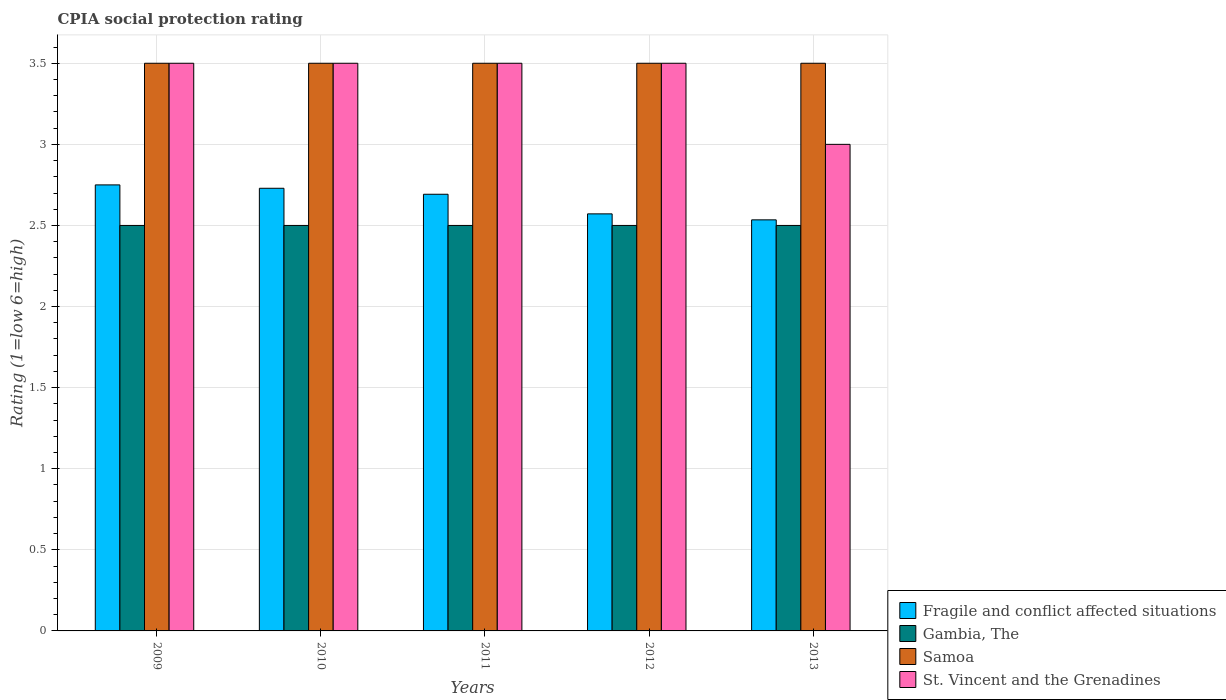How many groups of bars are there?
Your response must be concise. 5. Are the number of bars on each tick of the X-axis equal?
Offer a very short reply. Yes. In how many cases, is the number of bars for a given year not equal to the number of legend labels?
Give a very brief answer. 0. Across all years, what is the minimum CPIA rating in Fragile and conflict affected situations?
Offer a terse response. 2.53. What is the total CPIA rating in Gambia, The in the graph?
Provide a short and direct response. 12.5. What is the difference between the CPIA rating in St. Vincent and the Grenadines in 2010 and that in 2013?
Your answer should be very brief. 0.5. What is the difference between the CPIA rating in St. Vincent and the Grenadines in 2010 and the CPIA rating in Fragile and conflict affected situations in 2012?
Ensure brevity in your answer.  0.93. What is the average CPIA rating in Fragile and conflict affected situations per year?
Your answer should be very brief. 2.66. Is the difference between the CPIA rating in Gambia, The in 2011 and 2012 greater than the difference between the CPIA rating in Samoa in 2011 and 2012?
Provide a succinct answer. No. What is the difference between the highest and the second highest CPIA rating in St. Vincent and the Grenadines?
Your response must be concise. 0. Is it the case that in every year, the sum of the CPIA rating in Gambia, The and CPIA rating in Samoa is greater than the sum of CPIA rating in Fragile and conflict affected situations and CPIA rating in St. Vincent and the Grenadines?
Provide a short and direct response. No. What does the 2nd bar from the left in 2010 represents?
Give a very brief answer. Gambia, The. What does the 3rd bar from the right in 2009 represents?
Offer a very short reply. Gambia, The. Is it the case that in every year, the sum of the CPIA rating in Samoa and CPIA rating in Fragile and conflict affected situations is greater than the CPIA rating in Gambia, The?
Make the answer very short. Yes. How many years are there in the graph?
Your response must be concise. 5. What is the difference between two consecutive major ticks on the Y-axis?
Give a very brief answer. 0.5. Does the graph contain grids?
Your answer should be compact. Yes. What is the title of the graph?
Ensure brevity in your answer.  CPIA social protection rating. Does "Virgin Islands" appear as one of the legend labels in the graph?
Your response must be concise. No. What is the label or title of the X-axis?
Keep it short and to the point. Years. What is the label or title of the Y-axis?
Keep it short and to the point. Rating (1=low 6=high). What is the Rating (1=low 6=high) of Fragile and conflict affected situations in 2009?
Ensure brevity in your answer.  2.75. What is the Rating (1=low 6=high) in Fragile and conflict affected situations in 2010?
Ensure brevity in your answer.  2.73. What is the Rating (1=low 6=high) of Fragile and conflict affected situations in 2011?
Your answer should be compact. 2.69. What is the Rating (1=low 6=high) of Samoa in 2011?
Keep it short and to the point. 3.5. What is the Rating (1=low 6=high) in Fragile and conflict affected situations in 2012?
Provide a short and direct response. 2.57. What is the Rating (1=low 6=high) in Gambia, The in 2012?
Keep it short and to the point. 2.5. What is the Rating (1=low 6=high) of Samoa in 2012?
Provide a succinct answer. 3.5. What is the Rating (1=low 6=high) in Fragile and conflict affected situations in 2013?
Provide a succinct answer. 2.53. What is the Rating (1=low 6=high) in Samoa in 2013?
Your answer should be compact. 3.5. Across all years, what is the maximum Rating (1=low 6=high) in Fragile and conflict affected situations?
Offer a very short reply. 2.75. Across all years, what is the maximum Rating (1=low 6=high) in Gambia, The?
Make the answer very short. 2.5. Across all years, what is the minimum Rating (1=low 6=high) of Fragile and conflict affected situations?
Give a very brief answer. 2.53. Across all years, what is the minimum Rating (1=low 6=high) of Samoa?
Offer a terse response. 3.5. Across all years, what is the minimum Rating (1=low 6=high) in St. Vincent and the Grenadines?
Provide a short and direct response. 3. What is the total Rating (1=low 6=high) in Fragile and conflict affected situations in the graph?
Ensure brevity in your answer.  13.28. What is the total Rating (1=low 6=high) of St. Vincent and the Grenadines in the graph?
Provide a succinct answer. 17. What is the difference between the Rating (1=low 6=high) of Fragile and conflict affected situations in 2009 and that in 2010?
Provide a succinct answer. 0.02. What is the difference between the Rating (1=low 6=high) in Gambia, The in 2009 and that in 2010?
Your answer should be compact. 0. What is the difference between the Rating (1=low 6=high) of Samoa in 2009 and that in 2010?
Your response must be concise. 0. What is the difference between the Rating (1=low 6=high) of St. Vincent and the Grenadines in 2009 and that in 2010?
Offer a terse response. 0. What is the difference between the Rating (1=low 6=high) of Fragile and conflict affected situations in 2009 and that in 2011?
Offer a terse response. 0.06. What is the difference between the Rating (1=low 6=high) in Samoa in 2009 and that in 2011?
Ensure brevity in your answer.  0. What is the difference between the Rating (1=low 6=high) in St. Vincent and the Grenadines in 2009 and that in 2011?
Provide a short and direct response. 0. What is the difference between the Rating (1=low 6=high) of Fragile and conflict affected situations in 2009 and that in 2012?
Your answer should be compact. 0.18. What is the difference between the Rating (1=low 6=high) in Gambia, The in 2009 and that in 2012?
Provide a short and direct response. 0. What is the difference between the Rating (1=low 6=high) of Samoa in 2009 and that in 2012?
Your answer should be compact. 0. What is the difference between the Rating (1=low 6=high) in Fragile and conflict affected situations in 2009 and that in 2013?
Make the answer very short. 0.22. What is the difference between the Rating (1=low 6=high) of Gambia, The in 2009 and that in 2013?
Make the answer very short. 0. What is the difference between the Rating (1=low 6=high) of Samoa in 2009 and that in 2013?
Your response must be concise. 0. What is the difference between the Rating (1=low 6=high) of St. Vincent and the Grenadines in 2009 and that in 2013?
Offer a very short reply. 0.5. What is the difference between the Rating (1=low 6=high) in Fragile and conflict affected situations in 2010 and that in 2011?
Your answer should be very brief. 0.04. What is the difference between the Rating (1=low 6=high) in Gambia, The in 2010 and that in 2011?
Provide a succinct answer. 0. What is the difference between the Rating (1=low 6=high) in Samoa in 2010 and that in 2011?
Offer a very short reply. 0. What is the difference between the Rating (1=low 6=high) of Fragile and conflict affected situations in 2010 and that in 2012?
Your answer should be compact. 0.16. What is the difference between the Rating (1=low 6=high) in Gambia, The in 2010 and that in 2012?
Make the answer very short. 0. What is the difference between the Rating (1=low 6=high) of Samoa in 2010 and that in 2012?
Your answer should be very brief. 0. What is the difference between the Rating (1=low 6=high) in Fragile and conflict affected situations in 2010 and that in 2013?
Offer a terse response. 0.19. What is the difference between the Rating (1=low 6=high) in Gambia, The in 2010 and that in 2013?
Provide a short and direct response. 0. What is the difference between the Rating (1=low 6=high) in Samoa in 2010 and that in 2013?
Your answer should be compact. 0. What is the difference between the Rating (1=low 6=high) in St. Vincent and the Grenadines in 2010 and that in 2013?
Provide a succinct answer. 0.5. What is the difference between the Rating (1=low 6=high) in Fragile and conflict affected situations in 2011 and that in 2012?
Provide a succinct answer. 0.12. What is the difference between the Rating (1=low 6=high) of Samoa in 2011 and that in 2012?
Provide a short and direct response. 0. What is the difference between the Rating (1=low 6=high) in St. Vincent and the Grenadines in 2011 and that in 2012?
Give a very brief answer. 0. What is the difference between the Rating (1=low 6=high) in Fragile and conflict affected situations in 2011 and that in 2013?
Give a very brief answer. 0.16. What is the difference between the Rating (1=low 6=high) in St. Vincent and the Grenadines in 2011 and that in 2013?
Offer a very short reply. 0.5. What is the difference between the Rating (1=low 6=high) of Fragile and conflict affected situations in 2012 and that in 2013?
Your answer should be very brief. 0.04. What is the difference between the Rating (1=low 6=high) of Gambia, The in 2012 and that in 2013?
Offer a terse response. 0. What is the difference between the Rating (1=low 6=high) in Samoa in 2012 and that in 2013?
Provide a short and direct response. 0. What is the difference between the Rating (1=low 6=high) in St. Vincent and the Grenadines in 2012 and that in 2013?
Provide a succinct answer. 0.5. What is the difference between the Rating (1=low 6=high) of Fragile and conflict affected situations in 2009 and the Rating (1=low 6=high) of Gambia, The in 2010?
Keep it short and to the point. 0.25. What is the difference between the Rating (1=low 6=high) in Fragile and conflict affected situations in 2009 and the Rating (1=low 6=high) in Samoa in 2010?
Your answer should be compact. -0.75. What is the difference between the Rating (1=low 6=high) of Fragile and conflict affected situations in 2009 and the Rating (1=low 6=high) of St. Vincent and the Grenadines in 2010?
Keep it short and to the point. -0.75. What is the difference between the Rating (1=low 6=high) in Gambia, The in 2009 and the Rating (1=low 6=high) in Samoa in 2010?
Ensure brevity in your answer.  -1. What is the difference between the Rating (1=low 6=high) of Gambia, The in 2009 and the Rating (1=low 6=high) of St. Vincent and the Grenadines in 2010?
Your answer should be compact. -1. What is the difference between the Rating (1=low 6=high) of Samoa in 2009 and the Rating (1=low 6=high) of St. Vincent and the Grenadines in 2010?
Offer a very short reply. 0. What is the difference between the Rating (1=low 6=high) in Fragile and conflict affected situations in 2009 and the Rating (1=low 6=high) in Gambia, The in 2011?
Your answer should be compact. 0.25. What is the difference between the Rating (1=low 6=high) of Fragile and conflict affected situations in 2009 and the Rating (1=low 6=high) of Samoa in 2011?
Your response must be concise. -0.75. What is the difference between the Rating (1=low 6=high) in Fragile and conflict affected situations in 2009 and the Rating (1=low 6=high) in St. Vincent and the Grenadines in 2011?
Give a very brief answer. -0.75. What is the difference between the Rating (1=low 6=high) in Gambia, The in 2009 and the Rating (1=low 6=high) in Samoa in 2011?
Offer a very short reply. -1. What is the difference between the Rating (1=low 6=high) in Gambia, The in 2009 and the Rating (1=low 6=high) in St. Vincent and the Grenadines in 2011?
Your answer should be very brief. -1. What is the difference between the Rating (1=low 6=high) in Samoa in 2009 and the Rating (1=low 6=high) in St. Vincent and the Grenadines in 2011?
Offer a very short reply. 0. What is the difference between the Rating (1=low 6=high) in Fragile and conflict affected situations in 2009 and the Rating (1=low 6=high) in Gambia, The in 2012?
Provide a succinct answer. 0.25. What is the difference between the Rating (1=low 6=high) of Fragile and conflict affected situations in 2009 and the Rating (1=low 6=high) of Samoa in 2012?
Offer a terse response. -0.75. What is the difference between the Rating (1=low 6=high) of Fragile and conflict affected situations in 2009 and the Rating (1=low 6=high) of St. Vincent and the Grenadines in 2012?
Keep it short and to the point. -0.75. What is the difference between the Rating (1=low 6=high) in Gambia, The in 2009 and the Rating (1=low 6=high) in Samoa in 2012?
Make the answer very short. -1. What is the difference between the Rating (1=low 6=high) of Gambia, The in 2009 and the Rating (1=low 6=high) of St. Vincent and the Grenadines in 2012?
Provide a succinct answer. -1. What is the difference between the Rating (1=low 6=high) in Samoa in 2009 and the Rating (1=low 6=high) in St. Vincent and the Grenadines in 2012?
Your answer should be very brief. 0. What is the difference between the Rating (1=low 6=high) in Fragile and conflict affected situations in 2009 and the Rating (1=low 6=high) in Samoa in 2013?
Your answer should be very brief. -0.75. What is the difference between the Rating (1=low 6=high) of Gambia, The in 2009 and the Rating (1=low 6=high) of St. Vincent and the Grenadines in 2013?
Offer a very short reply. -0.5. What is the difference between the Rating (1=low 6=high) in Fragile and conflict affected situations in 2010 and the Rating (1=low 6=high) in Gambia, The in 2011?
Provide a short and direct response. 0.23. What is the difference between the Rating (1=low 6=high) in Fragile and conflict affected situations in 2010 and the Rating (1=low 6=high) in Samoa in 2011?
Offer a terse response. -0.77. What is the difference between the Rating (1=low 6=high) of Fragile and conflict affected situations in 2010 and the Rating (1=low 6=high) of St. Vincent and the Grenadines in 2011?
Ensure brevity in your answer.  -0.77. What is the difference between the Rating (1=low 6=high) in Gambia, The in 2010 and the Rating (1=low 6=high) in Samoa in 2011?
Keep it short and to the point. -1. What is the difference between the Rating (1=low 6=high) in Samoa in 2010 and the Rating (1=low 6=high) in St. Vincent and the Grenadines in 2011?
Offer a terse response. 0. What is the difference between the Rating (1=low 6=high) in Fragile and conflict affected situations in 2010 and the Rating (1=low 6=high) in Gambia, The in 2012?
Your answer should be compact. 0.23. What is the difference between the Rating (1=low 6=high) in Fragile and conflict affected situations in 2010 and the Rating (1=low 6=high) in Samoa in 2012?
Your answer should be very brief. -0.77. What is the difference between the Rating (1=low 6=high) in Fragile and conflict affected situations in 2010 and the Rating (1=low 6=high) in St. Vincent and the Grenadines in 2012?
Your answer should be very brief. -0.77. What is the difference between the Rating (1=low 6=high) in Gambia, The in 2010 and the Rating (1=low 6=high) in Samoa in 2012?
Keep it short and to the point. -1. What is the difference between the Rating (1=low 6=high) of Fragile and conflict affected situations in 2010 and the Rating (1=low 6=high) of Gambia, The in 2013?
Provide a succinct answer. 0.23. What is the difference between the Rating (1=low 6=high) in Fragile and conflict affected situations in 2010 and the Rating (1=low 6=high) in Samoa in 2013?
Keep it short and to the point. -0.77. What is the difference between the Rating (1=low 6=high) of Fragile and conflict affected situations in 2010 and the Rating (1=low 6=high) of St. Vincent and the Grenadines in 2013?
Ensure brevity in your answer.  -0.27. What is the difference between the Rating (1=low 6=high) in Gambia, The in 2010 and the Rating (1=low 6=high) in Samoa in 2013?
Provide a succinct answer. -1. What is the difference between the Rating (1=low 6=high) of Fragile and conflict affected situations in 2011 and the Rating (1=low 6=high) of Gambia, The in 2012?
Offer a very short reply. 0.19. What is the difference between the Rating (1=low 6=high) in Fragile and conflict affected situations in 2011 and the Rating (1=low 6=high) in Samoa in 2012?
Your response must be concise. -0.81. What is the difference between the Rating (1=low 6=high) in Fragile and conflict affected situations in 2011 and the Rating (1=low 6=high) in St. Vincent and the Grenadines in 2012?
Offer a terse response. -0.81. What is the difference between the Rating (1=low 6=high) in Gambia, The in 2011 and the Rating (1=low 6=high) in Samoa in 2012?
Your response must be concise. -1. What is the difference between the Rating (1=low 6=high) of Gambia, The in 2011 and the Rating (1=low 6=high) of St. Vincent and the Grenadines in 2012?
Provide a succinct answer. -1. What is the difference between the Rating (1=low 6=high) in Samoa in 2011 and the Rating (1=low 6=high) in St. Vincent and the Grenadines in 2012?
Offer a terse response. 0. What is the difference between the Rating (1=low 6=high) of Fragile and conflict affected situations in 2011 and the Rating (1=low 6=high) of Gambia, The in 2013?
Give a very brief answer. 0.19. What is the difference between the Rating (1=low 6=high) of Fragile and conflict affected situations in 2011 and the Rating (1=low 6=high) of Samoa in 2013?
Provide a short and direct response. -0.81. What is the difference between the Rating (1=low 6=high) of Fragile and conflict affected situations in 2011 and the Rating (1=low 6=high) of St. Vincent and the Grenadines in 2013?
Your response must be concise. -0.31. What is the difference between the Rating (1=low 6=high) of Gambia, The in 2011 and the Rating (1=low 6=high) of St. Vincent and the Grenadines in 2013?
Your answer should be very brief. -0.5. What is the difference between the Rating (1=low 6=high) in Fragile and conflict affected situations in 2012 and the Rating (1=low 6=high) in Gambia, The in 2013?
Your response must be concise. 0.07. What is the difference between the Rating (1=low 6=high) in Fragile and conflict affected situations in 2012 and the Rating (1=low 6=high) in Samoa in 2013?
Provide a short and direct response. -0.93. What is the difference between the Rating (1=low 6=high) in Fragile and conflict affected situations in 2012 and the Rating (1=low 6=high) in St. Vincent and the Grenadines in 2013?
Ensure brevity in your answer.  -0.43. What is the difference between the Rating (1=low 6=high) of Gambia, The in 2012 and the Rating (1=low 6=high) of Samoa in 2013?
Your answer should be very brief. -1. What is the average Rating (1=low 6=high) in Fragile and conflict affected situations per year?
Ensure brevity in your answer.  2.66. What is the average Rating (1=low 6=high) of Gambia, The per year?
Provide a succinct answer. 2.5. In the year 2009, what is the difference between the Rating (1=low 6=high) in Fragile and conflict affected situations and Rating (1=low 6=high) in Gambia, The?
Make the answer very short. 0.25. In the year 2009, what is the difference between the Rating (1=low 6=high) of Fragile and conflict affected situations and Rating (1=low 6=high) of Samoa?
Offer a very short reply. -0.75. In the year 2009, what is the difference between the Rating (1=low 6=high) of Fragile and conflict affected situations and Rating (1=low 6=high) of St. Vincent and the Grenadines?
Offer a terse response. -0.75. In the year 2009, what is the difference between the Rating (1=low 6=high) of Samoa and Rating (1=low 6=high) of St. Vincent and the Grenadines?
Give a very brief answer. 0. In the year 2010, what is the difference between the Rating (1=low 6=high) of Fragile and conflict affected situations and Rating (1=low 6=high) of Gambia, The?
Your response must be concise. 0.23. In the year 2010, what is the difference between the Rating (1=low 6=high) in Fragile and conflict affected situations and Rating (1=low 6=high) in Samoa?
Give a very brief answer. -0.77. In the year 2010, what is the difference between the Rating (1=low 6=high) in Fragile and conflict affected situations and Rating (1=low 6=high) in St. Vincent and the Grenadines?
Ensure brevity in your answer.  -0.77. In the year 2010, what is the difference between the Rating (1=low 6=high) of Gambia, The and Rating (1=low 6=high) of St. Vincent and the Grenadines?
Your response must be concise. -1. In the year 2011, what is the difference between the Rating (1=low 6=high) in Fragile and conflict affected situations and Rating (1=low 6=high) in Gambia, The?
Offer a terse response. 0.19. In the year 2011, what is the difference between the Rating (1=low 6=high) of Fragile and conflict affected situations and Rating (1=low 6=high) of Samoa?
Offer a very short reply. -0.81. In the year 2011, what is the difference between the Rating (1=low 6=high) of Fragile and conflict affected situations and Rating (1=low 6=high) of St. Vincent and the Grenadines?
Your response must be concise. -0.81. In the year 2011, what is the difference between the Rating (1=low 6=high) in Gambia, The and Rating (1=low 6=high) in Samoa?
Keep it short and to the point. -1. In the year 2011, what is the difference between the Rating (1=low 6=high) of Samoa and Rating (1=low 6=high) of St. Vincent and the Grenadines?
Ensure brevity in your answer.  0. In the year 2012, what is the difference between the Rating (1=low 6=high) of Fragile and conflict affected situations and Rating (1=low 6=high) of Gambia, The?
Give a very brief answer. 0.07. In the year 2012, what is the difference between the Rating (1=low 6=high) in Fragile and conflict affected situations and Rating (1=low 6=high) in Samoa?
Give a very brief answer. -0.93. In the year 2012, what is the difference between the Rating (1=low 6=high) of Fragile and conflict affected situations and Rating (1=low 6=high) of St. Vincent and the Grenadines?
Keep it short and to the point. -0.93. In the year 2012, what is the difference between the Rating (1=low 6=high) in Gambia, The and Rating (1=low 6=high) in Samoa?
Keep it short and to the point. -1. In the year 2012, what is the difference between the Rating (1=low 6=high) of Samoa and Rating (1=low 6=high) of St. Vincent and the Grenadines?
Offer a terse response. 0. In the year 2013, what is the difference between the Rating (1=low 6=high) of Fragile and conflict affected situations and Rating (1=low 6=high) of Gambia, The?
Your answer should be very brief. 0.03. In the year 2013, what is the difference between the Rating (1=low 6=high) of Fragile and conflict affected situations and Rating (1=low 6=high) of Samoa?
Ensure brevity in your answer.  -0.97. In the year 2013, what is the difference between the Rating (1=low 6=high) in Fragile and conflict affected situations and Rating (1=low 6=high) in St. Vincent and the Grenadines?
Offer a terse response. -0.47. In the year 2013, what is the difference between the Rating (1=low 6=high) in Gambia, The and Rating (1=low 6=high) in St. Vincent and the Grenadines?
Offer a terse response. -0.5. What is the ratio of the Rating (1=low 6=high) of Fragile and conflict affected situations in 2009 to that in 2010?
Ensure brevity in your answer.  1.01. What is the ratio of the Rating (1=low 6=high) of St. Vincent and the Grenadines in 2009 to that in 2010?
Offer a terse response. 1. What is the ratio of the Rating (1=low 6=high) in Fragile and conflict affected situations in 2009 to that in 2011?
Give a very brief answer. 1.02. What is the ratio of the Rating (1=low 6=high) in Gambia, The in 2009 to that in 2011?
Provide a succinct answer. 1. What is the ratio of the Rating (1=low 6=high) of Samoa in 2009 to that in 2011?
Keep it short and to the point. 1. What is the ratio of the Rating (1=low 6=high) in Fragile and conflict affected situations in 2009 to that in 2012?
Offer a terse response. 1.07. What is the ratio of the Rating (1=low 6=high) of Gambia, The in 2009 to that in 2012?
Make the answer very short. 1. What is the ratio of the Rating (1=low 6=high) in St. Vincent and the Grenadines in 2009 to that in 2012?
Ensure brevity in your answer.  1. What is the ratio of the Rating (1=low 6=high) in Fragile and conflict affected situations in 2009 to that in 2013?
Provide a short and direct response. 1.08. What is the ratio of the Rating (1=low 6=high) of Gambia, The in 2009 to that in 2013?
Provide a succinct answer. 1. What is the ratio of the Rating (1=low 6=high) in Samoa in 2009 to that in 2013?
Make the answer very short. 1. What is the ratio of the Rating (1=low 6=high) in St. Vincent and the Grenadines in 2009 to that in 2013?
Offer a very short reply. 1.17. What is the ratio of the Rating (1=low 6=high) in Fragile and conflict affected situations in 2010 to that in 2011?
Offer a terse response. 1.01. What is the ratio of the Rating (1=low 6=high) of Samoa in 2010 to that in 2011?
Your answer should be very brief. 1. What is the ratio of the Rating (1=low 6=high) in Fragile and conflict affected situations in 2010 to that in 2012?
Your response must be concise. 1.06. What is the ratio of the Rating (1=low 6=high) in Gambia, The in 2010 to that in 2012?
Offer a very short reply. 1. What is the ratio of the Rating (1=low 6=high) of Samoa in 2010 to that in 2012?
Your response must be concise. 1. What is the ratio of the Rating (1=low 6=high) in St. Vincent and the Grenadines in 2010 to that in 2012?
Your answer should be very brief. 1. What is the ratio of the Rating (1=low 6=high) in Fragile and conflict affected situations in 2010 to that in 2013?
Your answer should be compact. 1.08. What is the ratio of the Rating (1=low 6=high) in Fragile and conflict affected situations in 2011 to that in 2012?
Provide a short and direct response. 1.05. What is the ratio of the Rating (1=low 6=high) in Gambia, The in 2011 to that in 2012?
Ensure brevity in your answer.  1. What is the ratio of the Rating (1=low 6=high) in Samoa in 2011 to that in 2012?
Ensure brevity in your answer.  1. What is the ratio of the Rating (1=low 6=high) in St. Vincent and the Grenadines in 2011 to that in 2012?
Your answer should be very brief. 1. What is the ratio of the Rating (1=low 6=high) of Fragile and conflict affected situations in 2011 to that in 2013?
Your response must be concise. 1.06. What is the ratio of the Rating (1=low 6=high) in Gambia, The in 2011 to that in 2013?
Your answer should be compact. 1. What is the ratio of the Rating (1=low 6=high) of Fragile and conflict affected situations in 2012 to that in 2013?
Ensure brevity in your answer.  1.01. What is the ratio of the Rating (1=low 6=high) in Samoa in 2012 to that in 2013?
Offer a terse response. 1. What is the difference between the highest and the second highest Rating (1=low 6=high) in Fragile and conflict affected situations?
Ensure brevity in your answer.  0.02. What is the difference between the highest and the second highest Rating (1=low 6=high) in Samoa?
Provide a succinct answer. 0. What is the difference between the highest and the second highest Rating (1=low 6=high) of St. Vincent and the Grenadines?
Offer a terse response. 0. What is the difference between the highest and the lowest Rating (1=low 6=high) of Fragile and conflict affected situations?
Your answer should be compact. 0.22. What is the difference between the highest and the lowest Rating (1=low 6=high) of Samoa?
Your answer should be very brief. 0. 